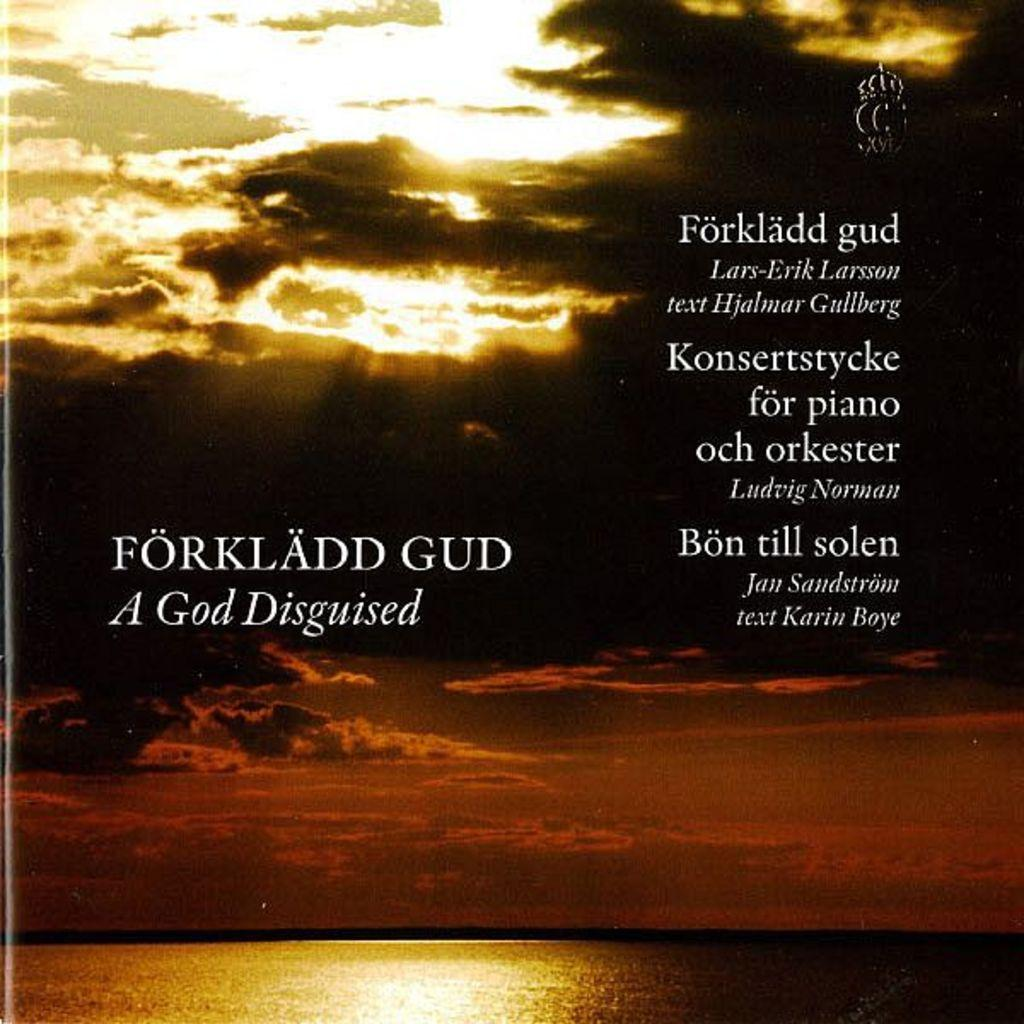Provide a one-sentence caption for the provided image. A darkened and cloudy sky with the text forkladd gud a god disguised on the left side. 